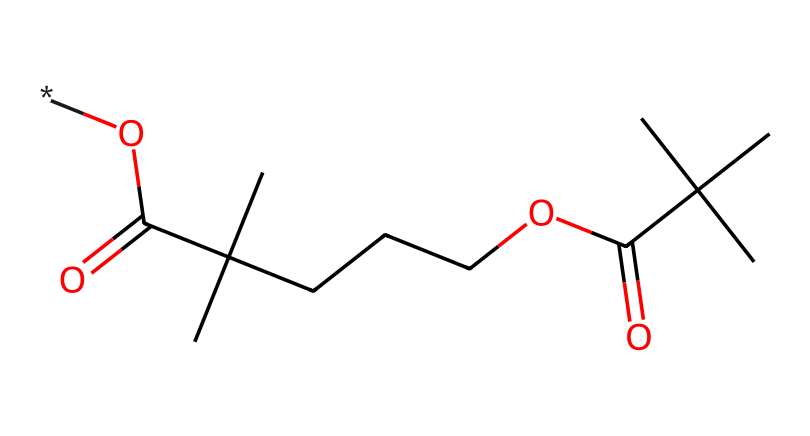What is the main functional group present in this chemical? The chemical structure contains a carboxylic acid functional group, which is indicated by the presence of the -COOH moiety. This is visible where carbon is double-bonded to oxygen and single-bonded to a hydroxyl group.
Answer: carboxylic acid How many carbon atoms are in this molecule? By analyzing the structure, we can count the carbon atoms present. There are eight carbon atoms in the main chain and branches. Hence, the total count is eight.
Answer: eight Is this chemical likely to be soluble in water? Polymers containing carboxylic acid groups typically have the potential for water solubility due to their polar nature. However, the large hydrophobic tail in this molecule suggests limited solubility.
Answer: limited What types of bonds are primarily present in this chemical? The structural representation shows both single and double bonds. The primary types present include C-H single bonds and the C=O double bonds from the carboxylic acid groups.
Answer: single and double bonds How many carboxylic acid groups does this structure contain? Upon reviewing the structure, there are two distinct carboxylic acid groups clearly visible at opposite ends of the molecule. Therefore, the count is two.
Answer: two 